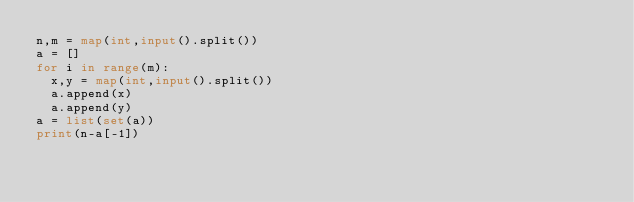<code> <loc_0><loc_0><loc_500><loc_500><_Python_>n,m = map(int,input().split())
a = []
for i in range(m):
  x,y = map(int,input().split())
  a.append(x)
  a.append(y)
a = list(set(a))
print(n-a[-1])</code> 